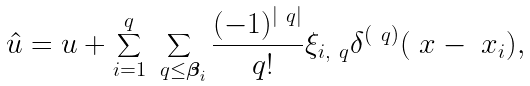Convert formula to latex. <formula><loc_0><loc_0><loc_500><loc_500>\hat { u } = u + \sum _ { i = 1 } ^ { q } \sum _ { \ q \leq \boldsymbol \beta _ { i } } \frac { ( - 1 ) ^ { | \ q | } } { \ q ! } \xi _ { i , \ q } \delta ^ { ( \ q ) } ( \ x - \ x _ { i } ) ,</formula> 